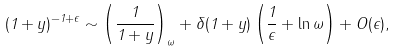Convert formula to latex. <formula><loc_0><loc_0><loc_500><loc_500>( 1 + y ) ^ { - 1 + \epsilon } \sim \left ( \frac { 1 } { 1 + y } \right ) _ { \omega } + \delta ( 1 + y ) \left ( \frac { 1 } { \epsilon } + \ln \omega \right ) + O ( \epsilon ) ,</formula> 